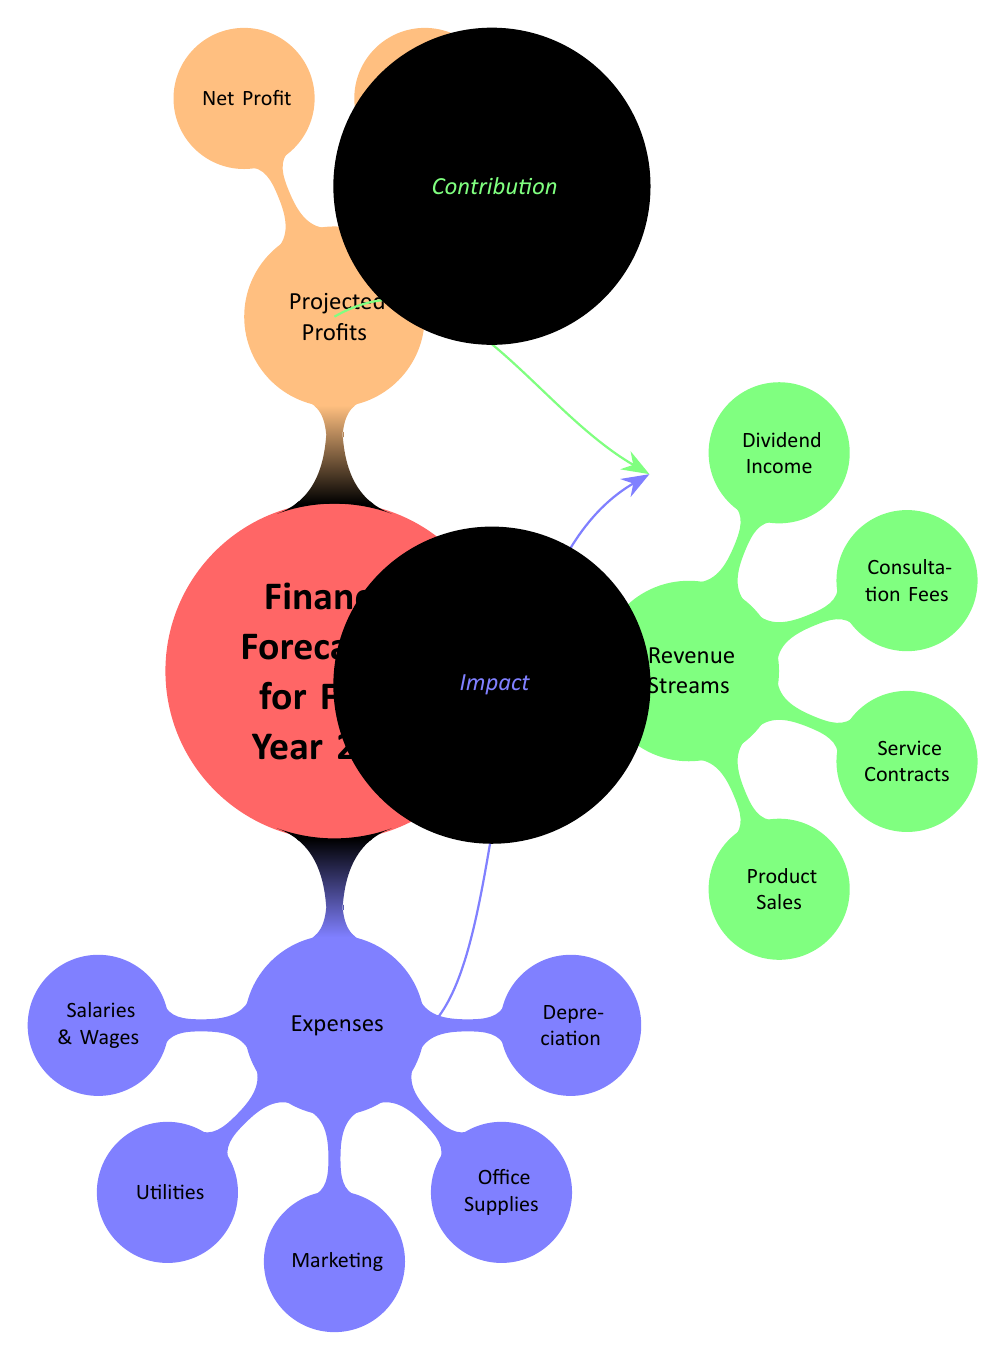What is the main focus of the diagram? The diagram centers on "Financial Forecasting for Fiscal Year 2024," indicated as the main title at the top, which establishes the overall subject matter of the analysis shown below.
Answer: Financial Forecasting for Fiscal Year 2024 How many main categories are represented in the diagram? The diagram contains three main categories: Expenses, Revenue Streams, and Projected Profits, clearly delineated in the first-level nodes branching from the central concept.
Answer: Three What are the components listed under Expenses? The diagram specifies five components under the Expenses category: Salaries & Wages, Utilities, Marketing, Office Supplies, and Depreciation, each represented as a separate node branching off from the Expenses node.
Answer: Salaries & Wages, Utilities, Marketing, Office Supplies, Depreciation Which category includes the node "Product Sales"? The node "Product Sales" is found under the Revenue Streams category, as evidenced by its position in the second-level nodes branching from the Revenue Streams node.
Answer: Revenue Streams What is the relationship between the Expenses and Revenue Streams categories? The diagram visually suggests a relationship wherein Expenses and Revenue Streams are interconnected through arrows indicating "Impact" and "Contribution," highlighting how each influences the overall financial forecasting.
Answer: Impact and Contribution How many revenue sources are identified in the diagram? There are four revenue sources detailed in the diagram under the Revenue Streams category: Product Sales, Service Contracts, Consultation Fees, and Dividend Income, each listed as separate nodes.
Answer: Four What type of profit is listed first under Projected Profits? The first type of profit mentioned under Projected Profits is "Gross Profit," which is positioned as the first node in that category, indicating its priority in the profit-related metrics of financial forecasting.
Answer: Gross Profit Which nodes signify the potential financial outcomes from the Revenue Streams category? The Projected Profits category nodes, namely Gross Profit and Net Profit, signify the potential financial outcomes resulting from the various Revenue Streams, connecting back to the contributions from revenues after accounting for expenses.
Answer: Gross Profit, Net Profit What visual cue indicates the influence of Expenses on the financial forecast? An arrow labeled "Impact" connects the Expenses node to the central concept, serving as a visual cue that emphasizes the influence of expenses on the overall financial forecast illustrated in the diagram.
Answer: Impact 